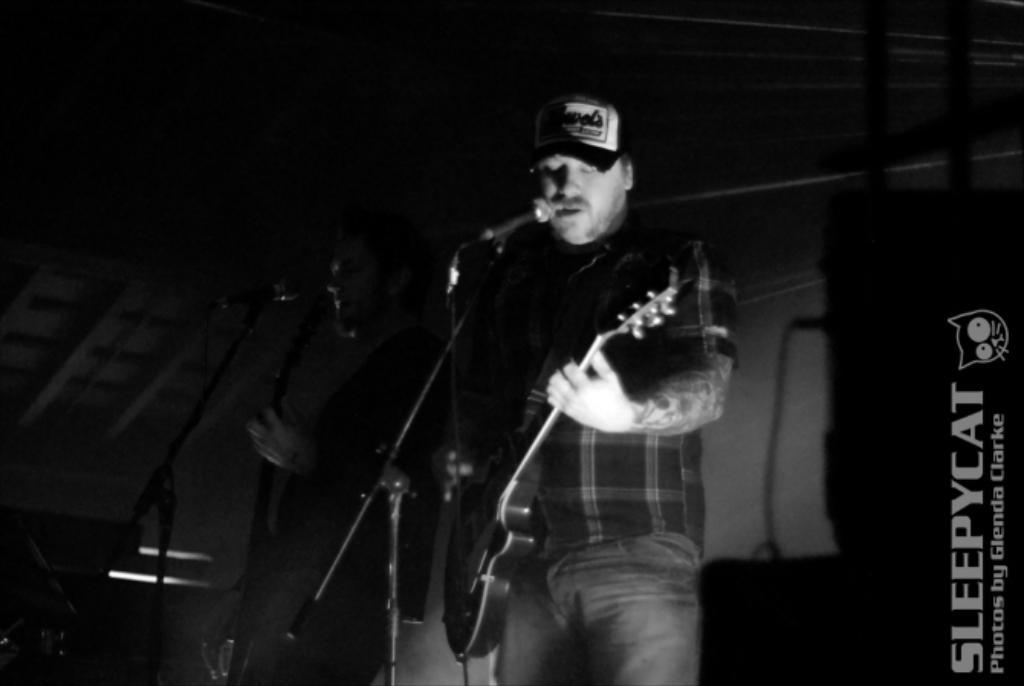How many people are in the image? There are two persons in the image. What are the people wearing? Both persons are wearing black shirts. What are the persons doing in the image? The persons are playing musical instruments. What objects are in front of the persons? There are microphones in front of the persons. How much debt do the persons in the image have? There is no information about the persons' debt in the image. What is the balance of the musical instruments in the image? The image does not provide information about the balance of the musical instruments. 